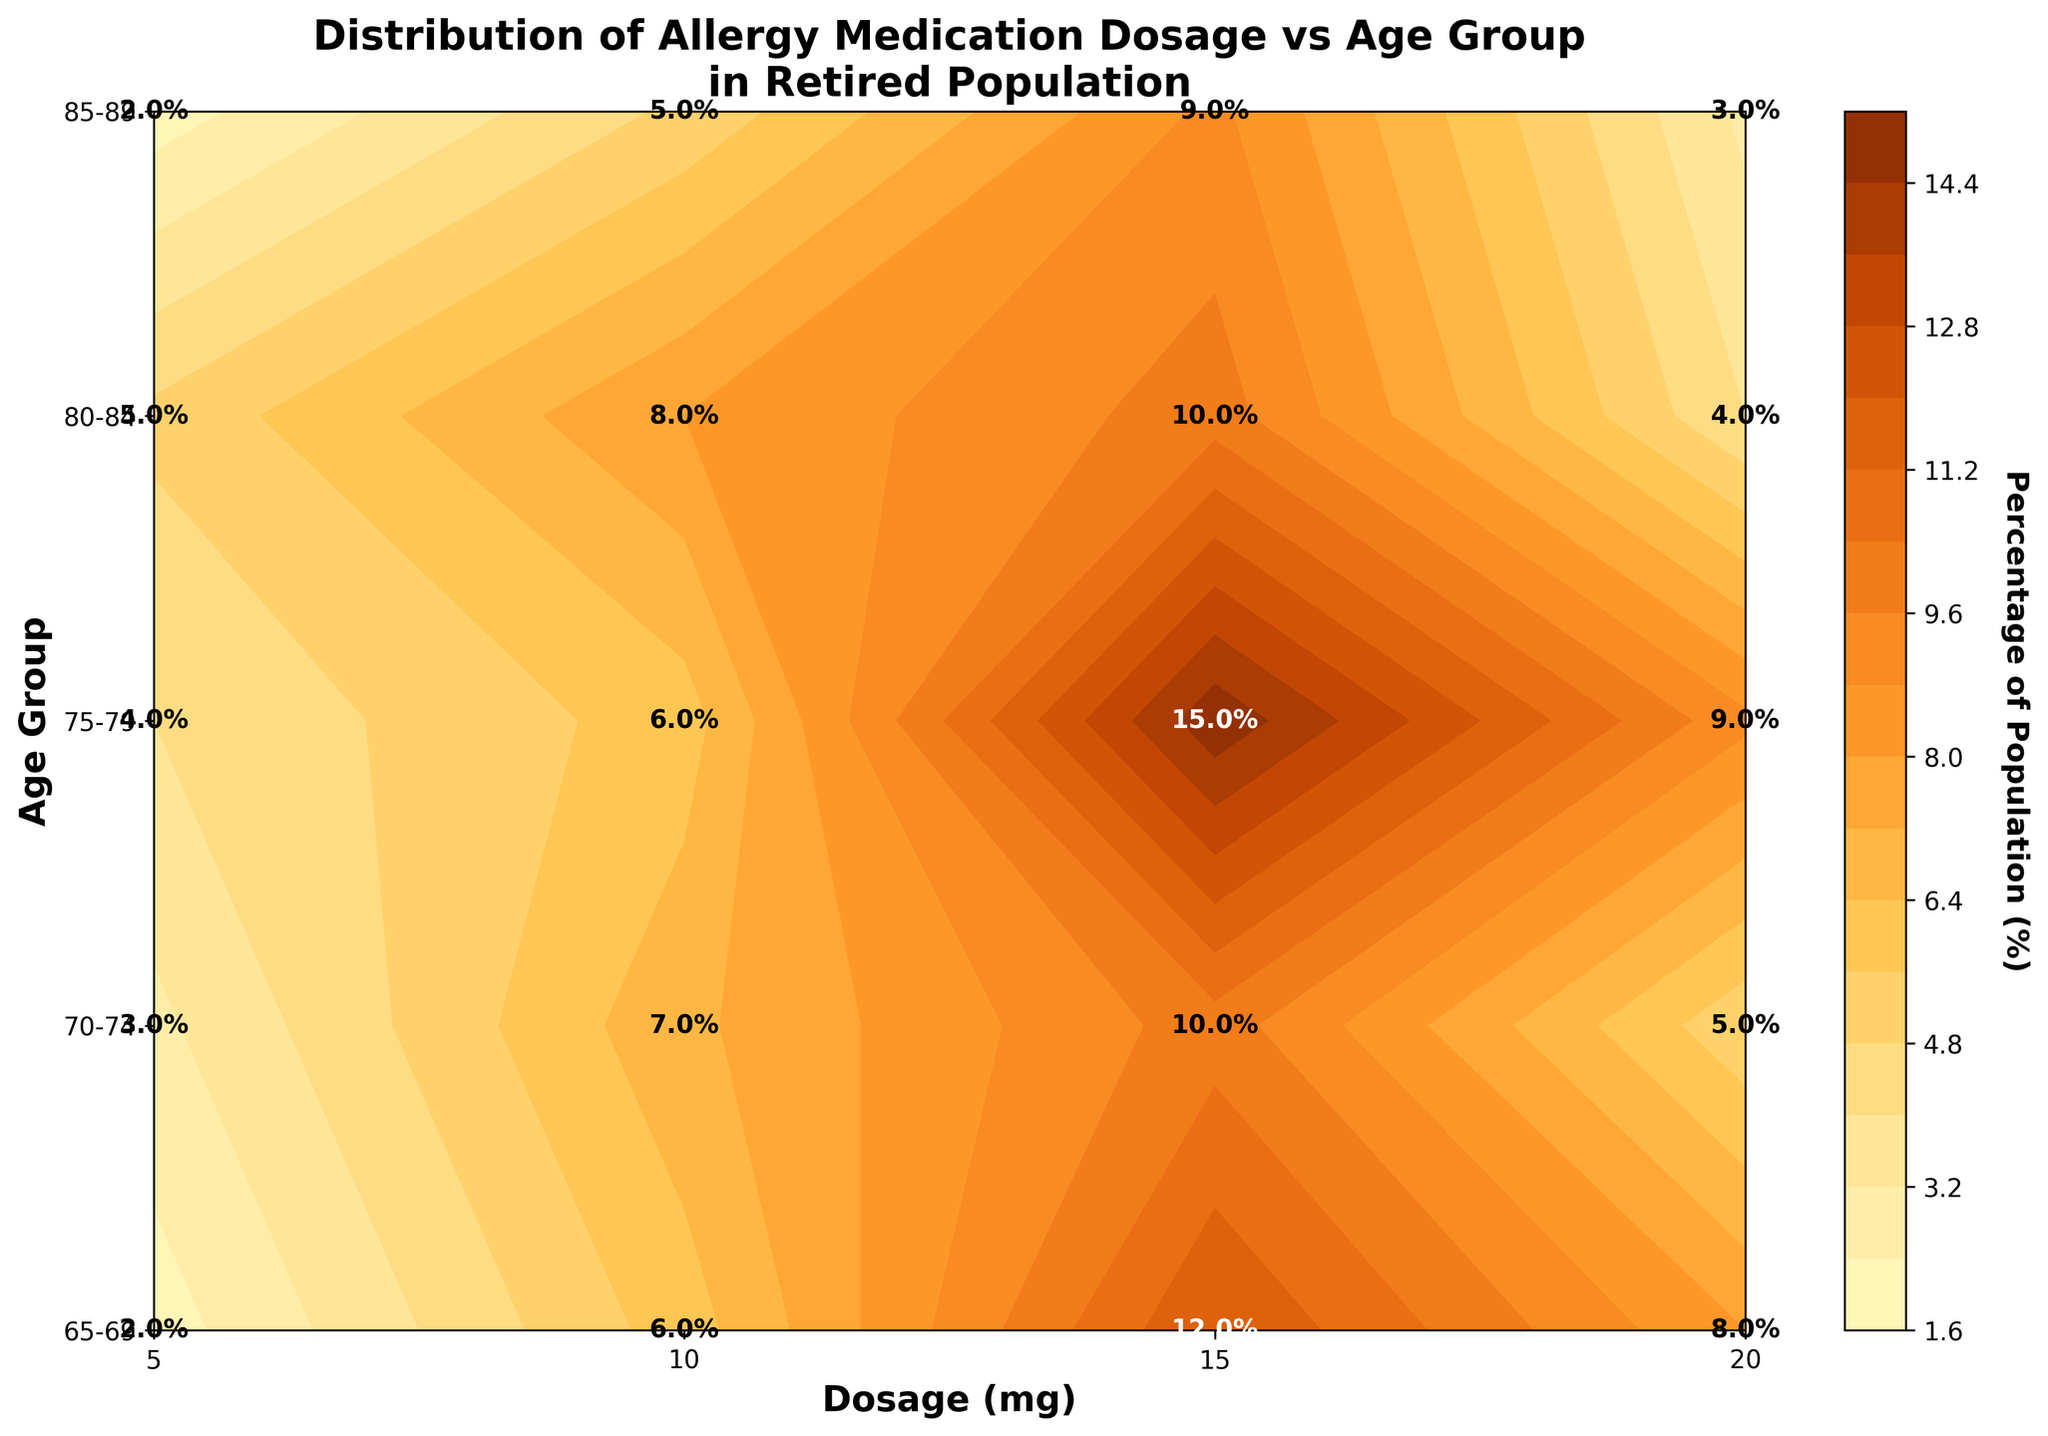What is the title of the plot? The title of the plot is prominently displayed at the top. It reads: "Distribution of Allergy Medication Dosage vs Age Group in Retired Population".
Answer: Distribution of Allergy Medication Dosage vs Age Group in Retired Population Which age group has the highest percentage for a 15 mg dosage? By examining the contour plot and focusing on the 15 mg dosage along the x-axis, we see that the 75-79 age group has the highest percentage of 15%.
Answer: 75-79 What is the percentage of the population in the 85-89 age group taking 10 mg dosages? On the y-axis, locate the 85-89 age group and move horizontally to the 10 mg dosage. The annotated text displays a percentage of 5%.
Answer: 5% Compare the percentage of the population taking 5 mg dosage between the 70-74 and 80-84 age groups. For each age group on the y-axis, focus on the 5 mg dosage line. The 70-74 age group shows 3%, while the 80-84 age group shows 5%. Thus, the 80-84 age group has a higher percentage.
Answer: 80-84 has higher What dosage has the lowest percentage across all age groups? The lowest percentage across all age groups is 2%, occurring with 5 mg in the 65-69 and 85-89 age groups.
Answer: 5 mg Which age group has the most consistent percentage across all dosages? By observing the plot, we note that the 80-84 age group has relatively small variations in percentages across different dosages (5-10%).
Answer: 80-84 What age group has the greatest variation in dosage percentages? The 65-69 age group shows the greatest variation. Percentages range from 2% at 5 mg to 12% at 15 mg.
Answer: 65-69 If you are part of the 75-79 age group, between which dosages do the percentage differences exceed 5%? In the 75-79 age group, differences between dosages of 5 mg (4%) and 15 mg (15%) exceed 5%. Another notable difference is between 10 mg and 15 mg, though it is exactly 9%.
Answer: 5 mg and 15 mg What is the most common dosage for all age groups combined? By looking at the overall contour plot, 15 mg shows the highest frequency with elevated percentages across multiple age groups (65-69, 75-79).
Answer: 15 mg 